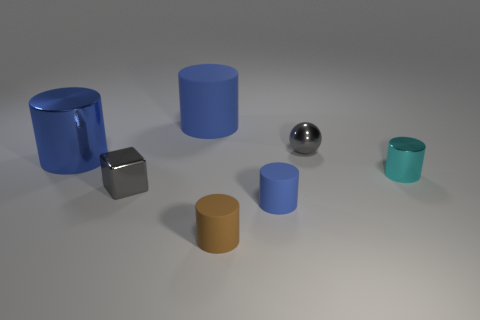What number of tiny things are either blue cylinders or blue metallic things?
Provide a short and direct response. 1. The large rubber thing has what color?
Provide a short and direct response. Blue. Is there a small block that is in front of the small gray metal thing in front of the small shiny cylinder?
Your answer should be compact. No. Are there fewer blue shiny objects to the left of the large blue shiny object than cyan cylinders?
Keep it short and to the point. Yes. Is the tiny gray object behind the cyan metal cylinder made of the same material as the small brown object?
Offer a very short reply. No. There is a cube that is the same material as the cyan object; what color is it?
Keep it short and to the point. Gray. Are there fewer small metal cubes that are in front of the brown cylinder than big blue cylinders in front of the small cyan metallic cylinder?
Provide a succinct answer. No. Does the shiny thing to the left of the cube have the same color as the shiny cube that is in front of the big rubber object?
Keep it short and to the point. No. Is there a small green sphere that has the same material as the gray sphere?
Your answer should be compact. No. There is a metal object behind the metallic object that is on the left side of the tiny gray block; how big is it?
Your response must be concise. Small. 